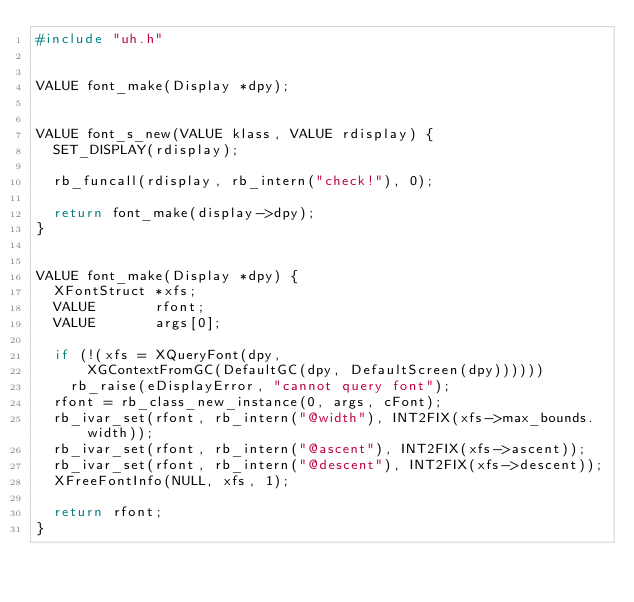Convert code to text. <code><loc_0><loc_0><loc_500><loc_500><_C_>#include "uh.h"


VALUE font_make(Display *dpy);


VALUE font_s_new(VALUE klass, VALUE rdisplay) {
  SET_DISPLAY(rdisplay);

  rb_funcall(rdisplay, rb_intern("check!"), 0);

  return font_make(display->dpy);
}


VALUE font_make(Display *dpy) {
  XFontStruct *xfs;
  VALUE       rfont;
  VALUE       args[0];

  if (!(xfs = XQueryFont(dpy,
      XGContextFromGC(DefaultGC(dpy, DefaultScreen(dpy))))))
    rb_raise(eDisplayError, "cannot query font");
  rfont = rb_class_new_instance(0, args, cFont);
  rb_ivar_set(rfont, rb_intern("@width"), INT2FIX(xfs->max_bounds.width));
  rb_ivar_set(rfont, rb_intern("@ascent"), INT2FIX(xfs->ascent));
  rb_ivar_set(rfont, rb_intern("@descent"), INT2FIX(xfs->descent));
  XFreeFontInfo(NULL, xfs, 1);

  return rfont;
}
</code> 